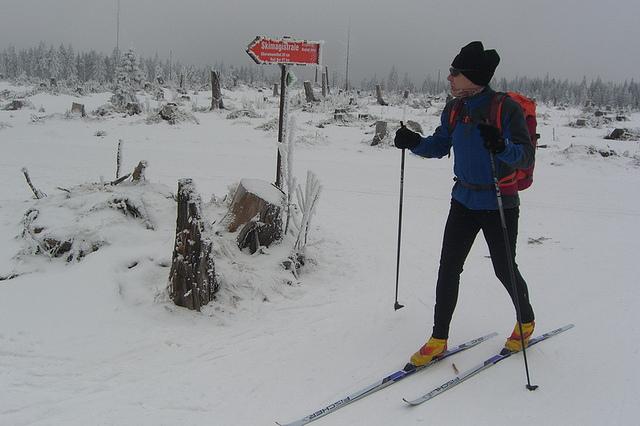Is this a contest?
Keep it brief. No. What color are his skis?
Short answer required. White. Is this person on his way to a trail?
Write a very short answer. Yes. Is there a shadow on this pic?
Concise answer only. No. Is there snow on the ground?
Keep it brief. Yes. What mountain was this taken at?
Concise answer only. Rushmore. What color is the sign?
Quick response, please. Red. 